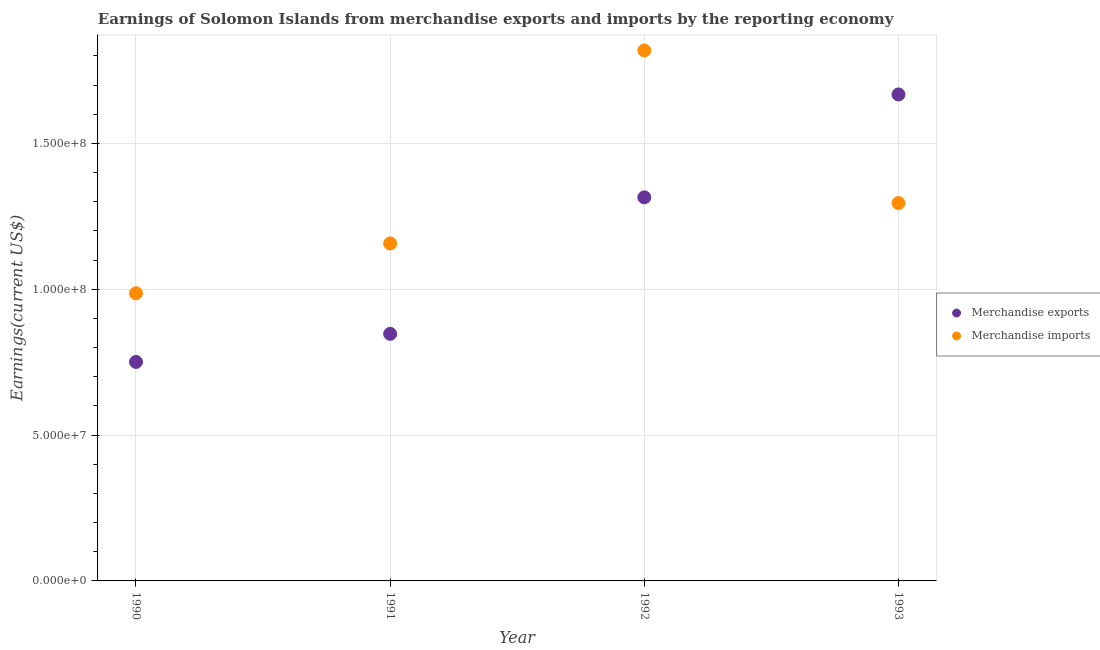What is the earnings from merchandise imports in 1991?
Keep it short and to the point. 1.16e+08. Across all years, what is the maximum earnings from merchandise imports?
Offer a very short reply. 1.82e+08. Across all years, what is the minimum earnings from merchandise exports?
Your answer should be very brief. 7.51e+07. What is the total earnings from merchandise imports in the graph?
Your answer should be compact. 5.26e+08. What is the difference between the earnings from merchandise imports in 1991 and that in 1992?
Offer a very short reply. -6.62e+07. What is the difference between the earnings from merchandise exports in 1990 and the earnings from merchandise imports in 1991?
Offer a terse response. -4.06e+07. What is the average earnings from merchandise imports per year?
Make the answer very short. 1.31e+08. In the year 1990, what is the difference between the earnings from merchandise exports and earnings from merchandise imports?
Offer a terse response. -2.35e+07. What is the ratio of the earnings from merchandise exports in 1990 to that in 1992?
Provide a short and direct response. 0.57. What is the difference between the highest and the second highest earnings from merchandise exports?
Ensure brevity in your answer.  3.53e+07. What is the difference between the highest and the lowest earnings from merchandise imports?
Your answer should be compact. 8.32e+07. Is the sum of the earnings from merchandise imports in 1991 and 1993 greater than the maximum earnings from merchandise exports across all years?
Make the answer very short. Yes. Is the earnings from merchandise exports strictly greater than the earnings from merchandise imports over the years?
Provide a succinct answer. No. How many years are there in the graph?
Your answer should be compact. 4. What is the difference between two consecutive major ticks on the Y-axis?
Make the answer very short. 5.00e+07. Are the values on the major ticks of Y-axis written in scientific E-notation?
Offer a very short reply. Yes. What is the title of the graph?
Your answer should be very brief. Earnings of Solomon Islands from merchandise exports and imports by the reporting economy. Does "Age 15+" appear as one of the legend labels in the graph?
Provide a short and direct response. No. What is the label or title of the X-axis?
Provide a short and direct response. Year. What is the label or title of the Y-axis?
Your response must be concise. Earnings(current US$). What is the Earnings(current US$) of Merchandise exports in 1990?
Keep it short and to the point. 7.51e+07. What is the Earnings(current US$) of Merchandise imports in 1990?
Offer a very short reply. 9.86e+07. What is the Earnings(current US$) of Merchandise exports in 1991?
Give a very brief answer. 8.47e+07. What is the Earnings(current US$) in Merchandise imports in 1991?
Your answer should be compact. 1.16e+08. What is the Earnings(current US$) in Merchandise exports in 1992?
Your response must be concise. 1.32e+08. What is the Earnings(current US$) of Merchandise imports in 1992?
Ensure brevity in your answer.  1.82e+08. What is the Earnings(current US$) in Merchandise exports in 1993?
Ensure brevity in your answer.  1.67e+08. What is the Earnings(current US$) in Merchandise imports in 1993?
Offer a very short reply. 1.30e+08. Across all years, what is the maximum Earnings(current US$) in Merchandise exports?
Provide a short and direct response. 1.67e+08. Across all years, what is the maximum Earnings(current US$) in Merchandise imports?
Keep it short and to the point. 1.82e+08. Across all years, what is the minimum Earnings(current US$) of Merchandise exports?
Provide a succinct answer. 7.51e+07. Across all years, what is the minimum Earnings(current US$) of Merchandise imports?
Give a very brief answer. 9.86e+07. What is the total Earnings(current US$) in Merchandise exports in the graph?
Give a very brief answer. 4.58e+08. What is the total Earnings(current US$) in Merchandise imports in the graph?
Give a very brief answer. 5.26e+08. What is the difference between the Earnings(current US$) in Merchandise exports in 1990 and that in 1991?
Make the answer very short. -9.63e+06. What is the difference between the Earnings(current US$) in Merchandise imports in 1990 and that in 1991?
Ensure brevity in your answer.  -1.71e+07. What is the difference between the Earnings(current US$) in Merchandise exports in 1990 and that in 1992?
Keep it short and to the point. -5.64e+07. What is the difference between the Earnings(current US$) in Merchandise imports in 1990 and that in 1992?
Provide a short and direct response. -8.32e+07. What is the difference between the Earnings(current US$) of Merchandise exports in 1990 and that in 1993?
Provide a succinct answer. -9.17e+07. What is the difference between the Earnings(current US$) in Merchandise imports in 1990 and that in 1993?
Provide a short and direct response. -3.09e+07. What is the difference between the Earnings(current US$) in Merchandise exports in 1991 and that in 1992?
Make the answer very short. -4.68e+07. What is the difference between the Earnings(current US$) in Merchandise imports in 1991 and that in 1992?
Offer a terse response. -6.62e+07. What is the difference between the Earnings(current US$) of Merchandise exports in 1991 and that in 1993?
Your answer should be very brief. -8.21e+07. What is the difference between the Earnings(current US$) of Merchandise imports in 1991 and that in 1993?
Your response must be concise. -1.39e+07. What is the difference between the Earnings(current US$) of Merchandise exports in 1992 and that in 1993?
Your answer should be compact. -3.53e+07. What is the difference between the Earnings(current US$) of Merchandise imports in 1992 and that in 1993?
Offer a terse response. 5.23e+07. What is the difference between the Earnings(current US$) of Merchandise exports in 1990 and the Earnings(current US$) of Merchandise imports in 1991?
Provide a succinct answer. -4.06e+07. What is the difference between the Earnings(current US$) in Merchandise exports in 1990 and the Earnings(current US$) in Merchandise imports in 1992?
Offer a very short reply. -1.07e+08. What is the difference between the Earnings(current US$) of Merchandise exports in 1990 and the Earnings(current US$) of Merchandise imports in 1993?
Offer a terse response. -5.45e+07. What is the difference between the Earnings(current US$) of Merchandise exports in 1991 and the Earnings(current US$) of Merchandise imports in 1992?
Provide a succinct answer. -9.72e+07. What is the difference between the Earnings(current US$) of Merchandise exports in 1991 and the Earnings(current US$) of Merchandise imports in 1993?
Your answer should be very brief. -4.48e+07. What is the difference between the Earnings(current US$) of Merchandise exports in 1992 and the Earnings(current US$) of Merchandise imports in 1993?
Offer a very short reply. 1.96e+06. What is the average Earnings(current US$) of Merchandise exports per year?
Make the answer very short. 1.15e+08. What is the average Earnings(current US$) of Merchandise imports per year?
Ensure brevity in your answer.  1.31e+08. In the year 1990, what is the difference between the Earnings(current US$) of Merchandise exports and Earnings(current US$) of Merchandise imports?
Give a very brief answer. -2.35e+07. In the year 1991, what is the difference between the Earnings(current US$) in Merchandise exports and Earnings(current US$) in Merchandise imports?
Give a very brief answer. -3.10e+07. In the year 1992, what is the difference between the Earnings(current US$) in Merchandise exports and Earnings(current US$) in Merchandise imports?
Your answer should be compact. -5.04e+07. In the year 1993, what is the difference between the Earnings(current US$) in Merchandise exports and Earnings(current US$) in Merchandise imports?
Ensure brevity in your answer.  3.72e+07. What is the ratio of the Earnings(current US$) in Merchandise exports in 1990 to that in 1991?
Provide a short and direct response. 0.89. What is the ratio of the Earnings(current US$) of Merchandise imports in 1990 to that in 1991?
Make the answer very short. 0.85. What is the ratio of the Earnings(current US$) of Merchandise exports in 1990 to that in 1992?
Provide a short and direct response. 0.57. What is the ratio of the Earnings(current US$) in Merchandise imports in 1990 to that in 1992?
Keep it short and to the point. 0.54. What is the ratio of the Earnings(current US$) of Merchandise exports in 1990 to that in 1993?
Offer a very short reply. 0.45. What is the ratio of the Earnings(current US$) in Merchandise imports in 1990 to that in 1993?
Ensure brevity in your answer.  0.76. What is the ratio of the Earnings(current US$) of Merchandise exports in 1991 to that in 1992?
Your answer should be very brief. 0.64. What is the ratio of the Earnings(current US$) of Merchandise imports in 1991 to that in 1992?
Provide a short and direct response. 0.64. What is the ratio of the Earnings(current US$) of Merchandise exports in 1991 to that in 1993?
Your answer should be very brief. 0.51. What is the ratio of the Earnings(current US$) in Merchandise imports in 1991 to that in 1993?
Make the answer very short. 0.89. What is the ratio of the Earnings(current US$) of Merchandise exports in 1992 to that in 1993?
Make the answer very short. 0.79. What is the ratio of the Earnings(current US$) of Merchandise imports in 1992 to that in 1993?
Provide a succinct answer. 1.4. What is the difference between the highest and the second highest Earnings(current US$) in Merchandise exports?
Your answer should be compact. 3.53e+07. What is the difference between the highest and the second highest Earnings(current US$) of Merchandise imports?
Make the answer very short. 5.23e+07. What is the difference between the highest and the lowest Earnings(current US$) in Merchandise exports?
Ensure brevity in your answer.  9.17e+07. What is the difference between the highest and the lowest Earnings(current US$) of Merchandise imports?
Offer a very short reply. 8.32e+07. 